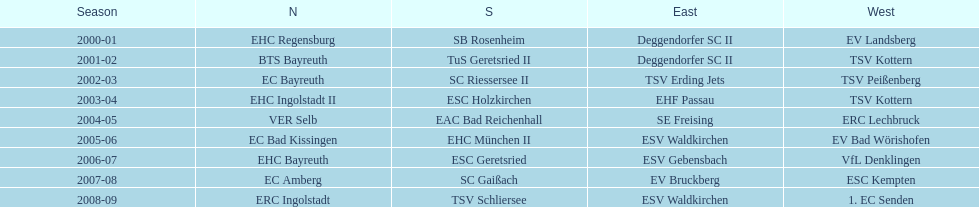The only team to win the north in 2000-01 season? EHC Regensburg. 